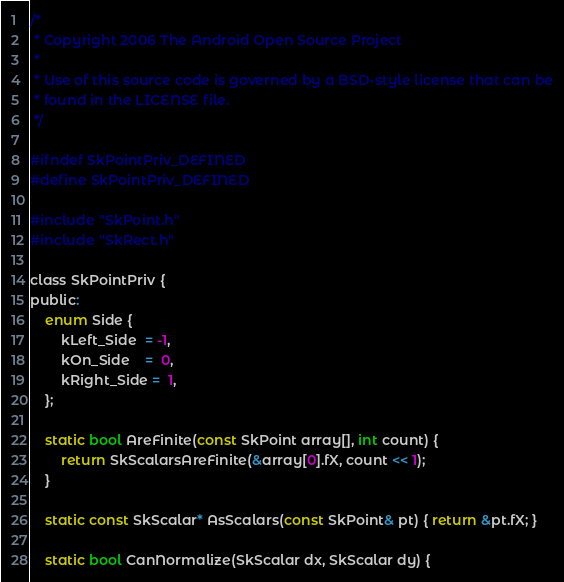Convert code to text. <code><loc_0><loc_0><loc_500><loc_500><_C_>/*
 * Copyright 2006 The Android Open Source Project
 *
 * Use of this source code is governed by a BSD-style license that can be
 * found in the LICENSE file.
 */

#ifndef SkPointPriv_DEFINED
#define SkPointPriv_DEFINED

#include "SkPoint.h"
#include "SkRect.h"

class SkPointPriv {
public:
    enum Side {
        kLeft_Side  = -1,
        kOn_Side    =  0,
        kRight_Side =  1,
    };

    static bool AreFinite(const SkPoint array[], int count) {
        return SkScalarsAreFinite(&array[0].fX, count << 1);
    }

    static const SkScalar* AsScalars(const SkPoint& pt) { return &pt.fX; }

    static bool CanNormalize(SkScalar dx, SkScalar dy) {</code> 